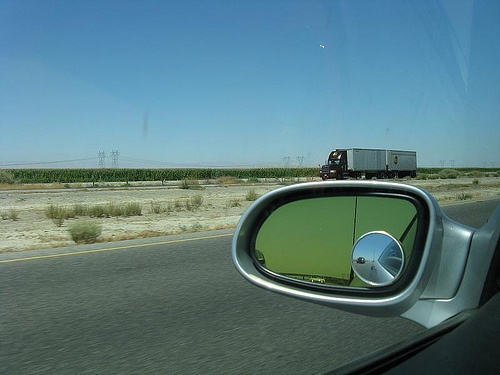Describe the objects in this image and their specific colors. I can see car in gray, black, and teal tones, truck in gray, teal, black, and darkgray tones, and truck in gray, darkgreen, and olive tones in this image. 